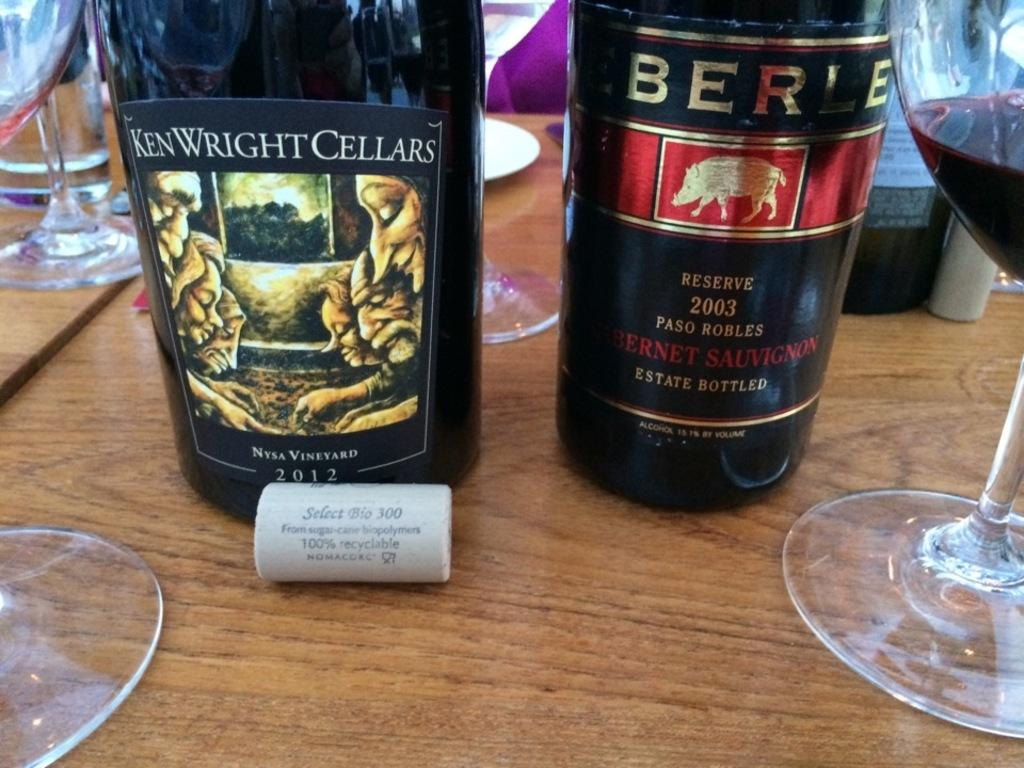Provide a one-sentence caption for the provided image. A bottle of Ken Wright Cellars is sitting on the table. 